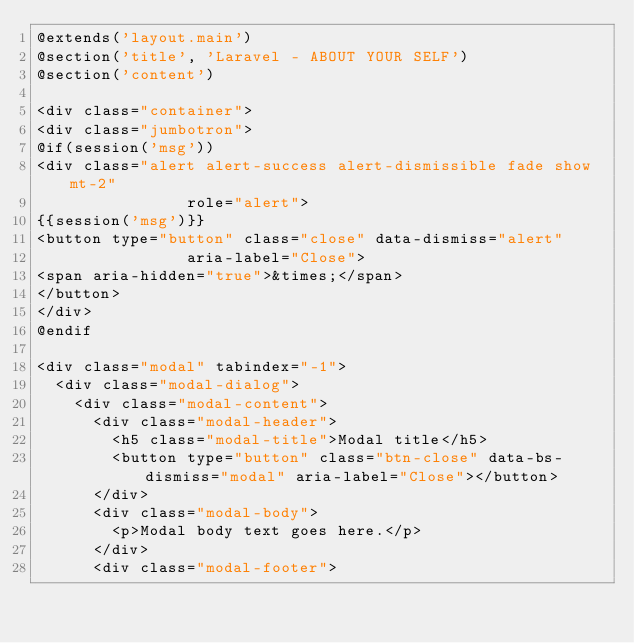<code> <loc_0><loc_0><loc_500><loc_500><_PHP_>@extends('layout.main')
@section('title', 'Laravel - ABOUT YOUR SELF')
@section('content')

<div class="container">
<div class="jumbotron">
@if(session('msg'))
<div class="alert alert-success alert-dismissible fade show mt-2"
                role="alert">
{{session('msg')}}
<button type="button" class="close" data-dismiss="alert"
                aria-label="Close">
<span aria-hidden="true">&times;</span>
</button>
</div>
@endif

<div class="modal" tabindex="-1">
  <div class="modal-dialog">
    <div class="modal-content">
      <div class="modal-header">
        <h5 class="modal-title">Modal title</h5>
        <button type="button" class="btn-close" data-bs-dismiss="modal" aria-label="Close"></button>
      </div>
      <div class="modal-body">
        <p>Modal body text goes here.</p>
      </div>
      <div class="modal-footer"></code> 